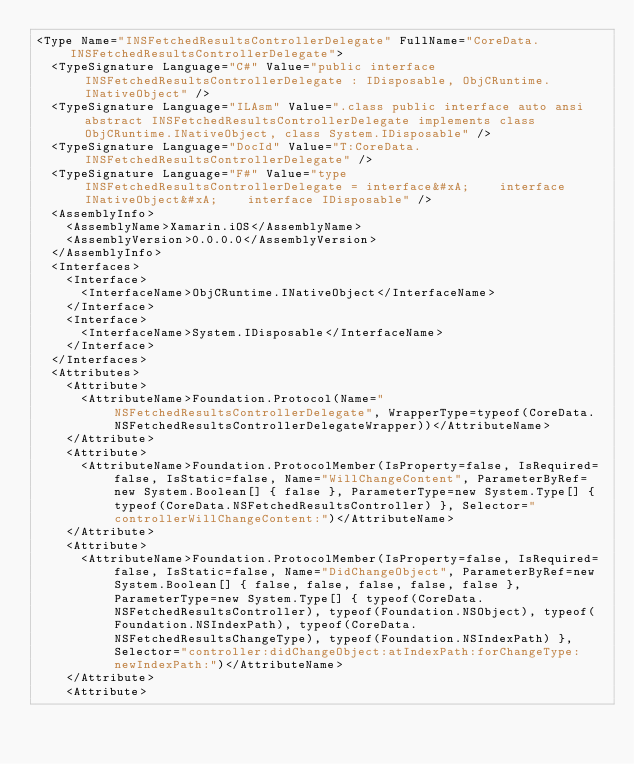Convert code to text. <code><loc_0><loc_0><loc_500><loc_500><_XML_><Type Name="INSFetchedResultsControllerDelegate" FullName="CoreData.INSFetchedResultsControllerDelegate">
  <TypeSignature Language="C#" Value="public interface INSFetchedResultsControllerDelegate : IDisposable, ObjCRuntime.INativeObject" />
  <TypeSignature Language="ILAsm" Value=".class public interface auto ansi abstract INSFetchedResultsControllerDelegate implements class ObjCRuntime.INativeObject, class System.IDisposable" />
  <TypeSignature Language="DocId" Value="T:CoreData.INSFetchedResultsControllerDelegate" />
  <TypeSignature Language="F#" Value="type INSFetchedResultsControllerDelegate = interface&#xA;    interface INativeObject&#xA;    interface IDisposable" />
  <AssemblyInfo>
    <AssemblyName>Xamarin.iOS</AssemblyName>
    <AssemblyVersion>0.0.0.0</AssemblyVersion>
  </AssemblyInfo>
  <Interfaces>
    <Interface>
      <InterfaceName>ObjCRuntime.INativeObject</InterfaceName>
    </Interface>
    <Interface>
      <InterfaceName>System.IDisposable</InterfaceName>
    </Interface>
  </Interfaces>
  <Attributes>
    <Attribute>
      <AttributeName>Foundation.Protocol(Name="NSFetchedResultsControllerDelegate", WrapperType=typeof(CoreData.NSFetchedResultsControllerDelegateWrapper))</AttributeName>
    </Attribute>
    <Attribute>
      <AttributeName>Foundation.ProtocolMember(IsProperty=false, IsRequired=false, IsStatic=false, Name="WillChangeContent", ParameterByRef=new System.Boolean[] { false }, ParameterType=new System.Type[] { typeof(CoreData.NSFetchedResultsController) }, Selector="controllerWillChangeContent:")</AttributeName>
    </Attribute>
    <Attribute>
      <AttributeName>Foundation.ProtocolMember(IsProperty=false, IsRequired=false, IsStatic=false, Name="DidChangeObject", ParameterByRef=new System.Boolean[] { false, false, false, false, false }, ParameterType=new System.Type[] { typeof(CoreData.NSFetchedResultsController), typeof(Foundation.NSObject), typeof(Foundation.NSIndexPath), typeof(CoreData.NSFetchedResultsChangeType), typeof(Foundation.NSIndexPath) }, Selector="controller:didChangeObject:atIndexPath:forChangeType:newIndexPath:")</AttributeName>
    </Attribute>
    <Attribute></code> 